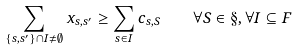Convert formula to latex. <formula><loc_0><loc_0><loc_500><loc_500>\sum _ { \{ s , s ^ { \prime } \} \cap I \neq \emptyset } x _ { s , s ^ { \prime } } \geq \sum _ { s \in I } c _ { s , S } \quad \forall S \in \S , \forall I \subseteq F</formula> 